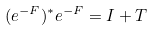Convert formula to latex. <formula><loc_0><loc_0><loc_500><loc_500>( e ^ { - F } ) ^ { * } e ^ { - F } = I + T</formula> 